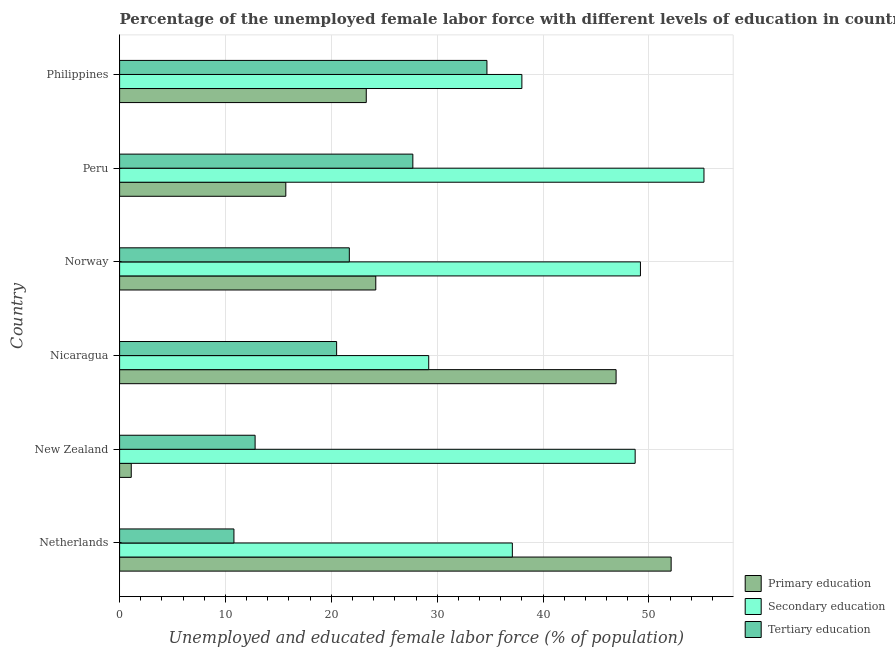How many different coloured bars are there?
Offer a very short reply. 3. How many groups of bars are there?
Your answer should be very brief. 6. How many bars are there on the 6th tick from the top?
Your answer should be compact. 3. How many bars are there on the 5th tick from the bottom?
Offer a very short reply. 3. What is the label of the 6th group of bars from the top?
Offer a terse response. Netherlands. What is the percentage of female labor force who received tertiary education in New Zealand?
Offer a terse response. 12.8. Across all countries, what is the maximum percentage of female labor force who received secondary education?
Ensure brevity in your answer.  55.2. Across all countries, what is the minimum percentage of female labor force who received primary education?
Keep it short and to the point. 1.1. In which country was the percentage of female labor force who received primary education minimum?
Ensure brevity in your answer.  New Zealand. What is the total percentage of female labor force who received tertiary education in the graph?
Your answer should be very brief. 128.2. What is the difference between the percentage of female labor force who received secondary education in Philippines and the percentage of female labor force who received primary education in Peru?
Provide a short and direct response. 22.3. What is the average percentage of female labor force who received primary education per country?
Your answer should be compact. 27.22. What is the difference between the percentage of female labor force who received secondary education and percentage of female labor force who received primary education in Netherlands?
Offer a very short reply. -15. What is the ratio of the percentage of female labor force who received secondary education in Netherlands to that in New Zealand?
Your answer should be compact. 0.76. Is the percentage of female labor force who received tertiary education in Netherlands less than that in Norway?
Provide a short and direct response. Yes. Is the difference between the percentage of female labor force who received tertiary education in New Zealand and Norway greater than the difference between the percentage of female labor force who received primary education in New Zealand and Norway?
Provide a succinct answer. Yes. What is the difference between the highest and the second highest percentage of female labor force who received secondary education?
Offer a very short reply. 6. What is the difference between the highest and the lowest percentage of female labor force who received secondary education?
Your response must be concise. 26. Is the sum of the percentage of female labor force who received tertiary education in Peru and Philippines greater than the maximum percentage of female labor force who received primary education across all countries?
Offer a terse response. Yes. What does the 1st bar from the top in Nicaragua represents?
Give a very brief answer. Tertiary education. What does the 1st bar from the bottom in Philippines represents?
Provide a short and direct response. Primary education. How many bars are there?
Your answer should be compact. 18. How many countries are there in the graph?
Give a very brief answer. 6. What is the difference between two consecutive major ticks on the X-axis?
Give a very brief answer. 10. Are the values on the major ticks of X-axis written in scientific E-notation?
Provide a short and direct response. No. Does the graph contain any zero values?
Your answer should be compact. No. Where does the legend appear in the graph?
Your response must be concise. Bottom right. How are the legend labels stacked?
Provide a succinct answer. Vertical. What is the title of the graph?
Your answer should be very brief. Percentage of the unemployed female labor force with different levels of education in countries. What is the label or title of the X-axis?
Ensure brevity in your answer.  Unemployed and educated female labor force (% of population). What is the Unemployed and educated female labor force (% of population) in Primary education in Netherlands?
Give a very brief answer. 52.1. What is the Unemployed and educated female labor force (% of population) in Secondary education in Netherlands?
Provide a succinct answer. 37.1. What is the Unemployed and educated female labor force (% of population) in Tertiary education in Netherlands?
Your response must be concise. 10.8. What is the Unemployed and educated female labor force (% of population) in Primary education in New Zealand?
Keep it short and to the point. 1.1. What is the Unemployed and educated female labor force (% of population) in Secondary education in New Zealand?
Keep it short and to the point. 48.7. What is the Unemployed and educated female labor force (% of population) of Tertiary education in New Zealand?
Keep it short and to the point. 12.8. What is the Unemployed and educated female labor force (% of population) in Primary education in Nicaragua?
Offer a terse response. 46.9. What is the Unemployed and educated female labor force (% of population) of Secondary education in Nicaragua?
Ensure brevity in your answer.  29.2. What is the Unemployed and educated female labor force (% of population) in Primary education in Norway?
Provide a succinct answer. 24.2. What is the Unemployed and educated female labor force (% of population) of Secondary education in Norway?
Your answer should be very brief. 49.2. What is the Unemployed and educated female labor force (% of population) of Tertiary education in Norway?
Make the answer very short. 21.7. What is the Unemployed and educated female labor force (% of population) of Primary education in Peru?
Provide a succinct answer. 15.7. What is the Unemployed and educated female labor force (% of population) of Secondary education in Peru?
Offer a terse response. 55.2. What is the Unemployed and educated female labor force (% of population) of Tertiary education in Peru?
Give a very brief answer. 27.7. What is the Unemployed and educated female labor force (% of population) in Primary education in Philippines?
Provide a short and direct response. 23.3. What is the Unemployed and educated female labor force (% of population) of Tertiary education in Philippines?
Give a very brief answer. 34.7. Across all countries, what is the maximum Unemployed and educated female labor force (% of population) of Primary education?
Provide a short and direct response. 52.1. Across all countries, what is the maximum Unemployed and educated female labor force (% of population) of Secondary education?
Make the answer very short. 55.2. Across all countries, what is the maximum Unemployed and educated female labor force (% of population) of Tertiary education?
Keep it short and to the point. 34.7. Across all countries, what is the minimum Unemployed and educated female labor force (% of population) of Primary education?
Your answer should be compact. 1.1. Across all countries, what is the minimum Unemployed and educated female labor force (% of population) in Secondary education?
Ensure brevity in your answer.  29.2. Across all countries, what is the minimum Unemployed and educated female labor force (% of population) of Tertiary education?
Offer a terse response. 10.8. What is the total Unemployed and educated female labor force (% of population) in Primary education in the graph?
Your response must be concise. 163.3. What is the total Unemployed and educated female labor force (% of population) of Secondary education in the graph?
Provide a succinct answer. 257.4. What is the total Unemployed and educated female labor force (% of population) in Tertiary education in the graph?
Provide a succinct answer. 128.2. What is the difference between the Unemployed and educated female labor force (% of population) in Primary education in Netherlands and that in Nicaragua?
Your response must be concise. 5.2. What is the difference between the Unemployed and educated female labor force (% of population) of Primary education in Netherlands and that in Norway?
Give a very brief answer. 27.9. What is the difference between the Unemployed and educated female labor force (% of population) of Primary education in Netherlands and that in Peru?
Provide a succinct answer. 36.4. What is the difference between the Unemployed and educated female labor force (% of population) in Secondary education in Netherlands and that in Peru?
Provide a short and direct response. -18.1. What is the difference between the Unemployed and educated female labor force (% of population) in Tertiary education in Netherlands and that in Peru?
Give a very brief answer. -16.9. What is the difference between the Unemployed and educated female labor force (% of population) in Primary education in Netherlands and that in Philippines?
Offer a very short reply. 28.8. What is the difference between the Unemployed and educated female labor force (% of population) of Tertiary education in Netherlands and that in Philippines?
Give a very brief answer. -23.9. What is the difference between the Unemployed and educated female labor force (% of population) in Primary education in New Zealand and that in Nicaragua?
Give a very brief answer. -45.8. What is the difference between the Unemployed and educated female labor force (% of population) in Primary education in New Zealand and that in Norway?
Keep it short and to the point. -23.1. What is the difference between the Unemployed and educated female labor force (% of population) of Primary education in New Zealand and that in Peru?
Your answer should be compact. -14.6. What is the difference between the Unemployed and educated female labor force (% of population) of Tertiary education in New Zealand and that in Peru?
Your answer should be very brief. -14.9. What is the difference between the Unemployed and educated female labor force (% of population) in Primary education in New Zealand and that in Philippines?
Provide a short and direct response. -22.2. What is the difference between the Unemployed and educated female labor force (% of population) in Tertiary education in New Zealand and that in Philippines?
Your answer should be very brief. -21.9. What is the difference between the Unemployed and educated female labor force (% of population) of Primary education in Nicaragua and that in Norway?
Provide a short and direct response. 22.7. What is the difference between the Unemployed and educated female labor force (% of population) of Secondary education in Nicaragua and that in Norway?
Ensure brevity in your answer.  -20. What is the difference between the Unemployed and educated female labor force (% of population) in Tertiary education in Nicaragua and that in Norway?
Make the answer very short. -1.2. What is the difference between the Unemployed and educated female labor force (% of population) of Primary education in Nicaragua and that in Peru?
Offer a very short reply. 31.2. What is the difference between the Unemployed and educated female labor force (% of population) in Secondary education in Nicaragua and that in Peru?
Offer a terse response. -26. What is the difference between the Unemployed and educated female labor force (% of population) of Primary education in Nicaragua and that in Philippines?
Provide a succinct answer. 23.6. What is the difference between the Unemployed and educated female labor force (% of population) of Secondary education in Norway and that in Philippines?
Your answer should be compact. 11.2. What is the difference between the Unemployed and educated female labor force (% of population) in Tertiary education in Norway and that in Philippines?
Offer a terse response. -13. What is the difference between the Unemployed and educated female labor force (% of population) in Primary education in Peru and that in Philippines?
Ensure brevity in your answer.  -7.6. What is the difference between the Unemployed and educated female labor force (% of population) of Secondary education in Peru and that in Philippines?
Give a very brief answer. 17.2. What is the difference between the Unemployed and educated female labor force (% of population) in Primary education in Netherlands and the Unemployed and educated female labor force (% of population) in Tertiary education in New Zealand?
Ensure brevity in your answer.  39.3. What is the difference between the Unemployed and educated female labor force (% of population) in Secondary education in Netherlands and the Unemployed and educated female labor force (% of population) in Tertiary education in New Zealand?
Offer a very short reply. 24.3. What is the difference between the Unemployed and educated female labor force (% of population) in Primary education in Netherlands and the Unemployed and educated female labor force (% of population) in Secondary education in Nicaragua?
Your answer should be very brief. 22.9. What is the difference between the Unemployed and educated female labor force (% of population) in Primary education in Netherlands and the Unemployed and educated female labor force (% of population) in Tertiary education in Nicaragua?
Offer a very short reply. 31.6. What is the difference between the Unemployed and educated female labor force (% of population) in Primary education in Netherlands and the Unemployed and educated female labor force (% of population) in Secondary education in Norway?
Keep it short and to the point. 2.9. What is the difference between the Unemployed and educated female labor force (% of population) in Primary education in Netherlands and the Unemployed and educated female labor force (% of population) in Tertiary education in Norway?
Provide a succinct answer. 30.4. What is the difference between the Unemployed and educated female labor force (% of population) in Primary education in Netherlands and the Unemployed and educated female labor force (% of population) in Tertiary education in Peru?
Your answer should be very brief. 24.4. What is the difference between the Unemployed and educated female labor force (% of population) in Secondary education in Netherlands and the Unemployed and educated female labor force (% of population) in Tertiary education in Peru?
Make the answer very short. 9.4. What is the difference between the Unemployed and educated female labor force (% of population) of Primary education in Netherlands and the Unemployed and educated female labor force (% of population) of Tertiary education in Philippines?
Keep it short and to the point. 17.4. What is the difference between the Unemployed and educated female labor force (% of population) in Secondary education in Netherlands and the Unemployed and educated female labor force (% of population) in Tertiary education in Philippines?
Your answer should be very brief. 2.4. What is the difference between the Unemployed and educated female labor force (% of population) of Primary education in New Zealand and the Unemployed and educated female labor force (% of population) of Secondary education in Nicaragua?
Give a very brief answer. -28.1. What is the difference between the Unemployed and educated female labor force (% of population) in Primary education in New Zealand and the Unemployed and educated female labor force (% of population) in Tertiary education in Nicaragua?
Give a very brief answer. -19.4. What is the difference between the Unemployed and educated female labor force (% of population) of Secondary education in New Zealand and the Unemployed and educated female labor force (% of population) of Tertiary education in Nicaragua?
Your answer should be very brief. 28.2. What is the difference between the Unemployed and educated female labor force (% of population) of Primary education in New Zealand and the Unemployed and educated female labor force (% of population) of Secondary education in Norway?
Provide a succinct answer. -48.1. What is the difference between the Unemployed and educated female labor force (% of population) of Primary education in New Zealand and the Unemployed and educated female labor force (% of population) of Tertiary education in Norway?
Ensure brevity in your answer.  -20.6. What is the difference between the Unemployed and educated female labor force (% of population) in Primary education in New Zealand and the Unemployed and educated female labor force (% of population) in Secondary education in Peru?
Offer a terse response. -54.1. What is the difference between the Unemployed and educated female labor force (% of population) of Primary education in New Zealand and the Unemployed and educated female labor force (% of population) of Tertiary education in Peru?
Provide a short and direct response. -26.6. What is the difference between the Unemployed and educated female labor force (% of population) in Primary education in New Zealand and the Unemployed and educated female labor force (% of population) in Secondary education in Philippines?
Keep it short and to the point. -36.9. What is the difference between the Unemployed and educated female labor force (% of population) in Primary education in New Zealand and the Unemployed and educated female labor force (% of population) in Tertiary education in Philippines?
Offer a very short reply. -33.6. What is the difference between the Unemployed and educated female labor force (% of population) in Primary education in Nicaragua and the Unemployed and educated female labor force (% of population) in Tertiary education in Norway?
Your answer should be compact. 25.2. What is the difference between the Unemployed and educated female labor force (% of population) of Primary education in Nicaragua and the Unemployed and educated female labor force (% of population) of Secondary education in Peru?
Ensure brevity in your answer.  -8.3. What is the difference between the Unemployed and educated female labor force (% of population) in Primary education in Nicaragua and the Unemployed and educated female labor force (% of population) in Tertiary education in Peru?
Your response must be concise. 19.2. What is the difference between the Unemployed and educated female labor force (% of population) in Primary education in Nicaragua and the Unemployed and educated female labor force (% of population) in Tertiary education in Philippines?
Make the answer very short. 12.2. What is the difference between the Unemployed and educated female labor force (% of population) in Secondary education in Nicaragua and the Unemployed and educated female labor force (% of population) in Tertiary education in Philippines?
Your answer should be very brief. -5.5. What is the difference between the Unemployed and educated female labor force (% of population) in Primary education in Norway and the Unemployed and educated female labor force (% of population) in Secondary education in Peru?
Give a very brief answer. -31. What is the difference between the Unemployed and educated female labor force (% of population) in Primary education in Norway and the Unemployed and educated female labor force (% of population) in Tertiary education in Peru?
Ensure brevity in your answer.  -3.5. What is the difference between the Unemployed and educated female labor force (% of population) of Primary education in Norway and the Unemployed and educated female labor force (% of population) of Secondary education in Philippines?
Offer a very short reply. -13.8. What is the difference between the Unemployed and educated female labor force (% of population) of Primary education in Norway and the Unemployed and educated female labor force (% of population) of Tertiary education in Philippines?
Your answer should be very brief. -10.5. What is the difference between the Unemployed and educated female labor force (% of population) in Primary education in Peru and the Unemployed and educated female labor force (% of population) in Secondary education in Philippines?
Offer a terse response. -22.3. What is the difference between the Unemployed and educated female labor force (% of population) in Primary education in Peru and the Unemployed and educated female labor force (% of population) in Tertiary education in Philippines?
Provide a short and direct response. -19. What is the average Unemployed and educated female labor force (% of population) of Primary education per country?
Provide a short and direct response. 27.22. What is the average Unemployed and educated female labor force (% of population) in Secondary education per country?
Your answer should be very brief. 42.9. What is the average Unemployed and educated female labor force (% of population) in Tertiary education per country?
Your answer should be compact. 21.37. What is the difference between the Unemployed and educated female labor force (% of population) of Primary education and Unemployed and educated female labor force (% of population) of Secondary education in Netherlands?
Ensure brevity in your answer.  15. What is the difference between the Unemployed and educated female labor force (% of population) in Primary education and Unemployed and educated female labor force (% of population) in Tertiary education in Netherlands?
Offer a terse response. 41.3. What is the difference between the Unemployed and educated female labor force (% of population) of Secondary education and Unemployed and educated female labor force (% of population) of Tertiary education in Netherlands?
Give a very brief answer. 26.3. What is the difference between the Unemployed and educated female labor force (% of population) of Primary education and Unemployed and educated female labor force (% of population) of Secondary education in New Zealand?
Offer a very short reply. -47.6. What is the difference between the Unemployed and educated female labor force (% of population) in Secondary education and Unemployed and educated female labor force (% of population) in Tertiary education in New Zealand?
Your response must be concise. 35.9. What is the difference between the Unemployed and educated female labor force (% of population) in Primary education and Unemployed and educated female labor force (% of population) in Tertiary education in Nicaragua?
Ensure brevity in your answer.  26.4. What is the difference between the Unemployed and educated female labor force (% of population) in Primary education and Unemployed and educated female labor force (% of population) in Secondary education in Norway?
Offer a terse response. -25. What is the difference between the Unemployed and educated female labor force (% of population) of Secondary education and Unemployed and educated female labor force (% of population) of Tertiary education in Norway?
Offer a terse response. 27.5. What is the difference between the Unemployed and educated female labor force (% of population) of Primary education and Unemployed and educated female labor force (% of population) of Secondary education in Peru?
Provide a short and direct response. -39.5. What is the difference between the Unemployed and educated female labor force (% of population) of Primary education and Unemployed and educated female labor force (% of population) of Tertiary education in Peru?
Ensure brevity in your answer.  -12. What is the difference between the Unemployed and educated female labor force (% of population) of Secondary education and Unemployed and educated female labor force (% of population) of Tertiary education in Peru?
Ensure brevity in your answer.  27.5. What is the difference between the Unemployed and educated female labor force (% of population) in Primary education and Unemployed and educated female labor force (% of population) in Secondary education in Philippines?
Make the answer very short. -14.7. What is the difference between the Unemployed and educated female labor force (% of population) of Primary education and Unemployed and educated female labor force (% of population) of Tertiary education in Philippines?
Keep it short and to the point. -11.4. What is the ratio of the Unemployed and educated female labor force (% of population) of Primary education in Netherlands to that in New Zealand?
Offer a terse response. 47.36. What is the ratio of the Unemployed and educated female labor force (% of population) in Secondary education in Netherlands to that in New Zealand?
Your answer should be compact. 0.76. What is the ratio of the Unemployed and educated female labor force (% of population) of Tertiary education in Netherlands to that in New Zealand?
Your answer should be very brief. 0.84. What is the ratio of the Unemployed and educated female labor force (% of population) of Primary education in Netherlands to that in Nicaragua?
Provide a short and direct response. 1.11. What is the ratio of the Unemployed and educated female labor force (% of population) in Secondary education in Netherlands to that in Nicaragua?
Provide a succinct answer. 1.27. What is the ratio of the Unemployed and educated female labor force (% of population) of Tertiary education in Netherlands to that in Nicaragua?
Offer a very short reply. 0.53. What is the ratio of the Unemployed and educated female labor force (% of population) in Primary education in Netherlands to that in Norway?
Provide a succinct answer. 2.15. What is the ratio of the Unemployed and educated female labor force (% of population) in Secondary education in Netherlands to that in Norway?
Offer a terse response. 0.75. What is the ratio of the Unemployed and educated female labor force (% of population) of Tertiary education in Netherlands to that in Norway?
Give a very brief answer. 0.5. What is the ratio of the Unemployed and educated female labor force (% of population) in Primary education in Netherlands to that in Peru?
Your answer should be very brief. 3.32. What is the ratio of the Unemployed and educated female labor force (% of population) of Secondary education in Netherlands to that in Peru?
Provide a succinct answer. 0.67. What is the ratio of the Unemployed and educated female labor force (% of population) in Tertiary education in Netherlands to that in Peru?
Your answer should be compact. 0.39. What is the ratio of the Unemployed and educated female labor force (% of population) of Primary education in Netherlands to that in Philippines?
Provide a short and direct response. 2.24. What is the ratio of the Unemployed and educated female labor force (% of population) of Secondary education in Netherlands to that in Philippines?
Provide a succinct answer. 0.98. What is the ratio of the Unemployed and educated female labor force (% of population) of Tertiary education in Netherlands to that in Philippines?
Your answer should be very brief. 0.31. What is the ratio of the Unemployed and educated female labor force (% of population) in Primary education in New Zealand to that in Nicaragua?
Provide a succinct answer. 0.02. What is the ratio of the Unemployed and educated female labor force (% of population) in Secondary education in New Zealand to that in Nicaragua?
Provide a short and direct response. 1.67. What is the ratio of the Unemployed and educated female labor force (% of population) in Tertiary education in New Zealand to that in Nicaragua?
Keep it short and to the point. 0.62. What is the ratio of the Unemployed and educated female labor force (% of population) of Primary education in New Zealand to that in Norway?
Offer a terse response. 0.05. What is the ratio of the Unemployed and educated female labor force (% of population) of Secondary education in New Zealand to that in Norway?
Offer a terse response. 0.99. What is the ratio of the Unemployed and educated female labor force (% of population) in Tertiary education in New Zealand to that in Norway?
Your response must be concise. 0.59. What is the ratio of the Unemployed and educated female labor force (% of population) of Primary education in New Zealand to that in Peru?
Ensure brevity in your answer.  0.07. What is the ratio of the Unemployed and educated female labor force (% of population) in Secondary education in New Zealand to that in Peru?
Your response must be concise. 0.88. What is the ratio of the Unemployed and educated female labor force (% of population) in Tertiary education in New Zealand to that in Peru?
Ensure brevity in your answer.  0.46. What is the ratio of the Unemployed and educated female labor force (% of population) in Primary education in New Zealand to that in Philippines?
Your response must be concise. 0.05. What is the ratio of the Unemployed and educated female labor force (% of population) of Secondary education in New Zealand to that in Philippines?
Give a very brief answer. 1.28. What is the ratio of the Unemployed and educated female labor force (% of population) of Tertiary education in New Zealand to that in Philippines?
Your answer should be very brief. 0.37. What is the ratio of the Unemployed and educated female labor force (% of population) in Primary education in Nicaragua to that in Norway?
Ensure brevity in your answer.  1.94. What is the ratio of the Unemployed and educated female labor force (% of population) of Secondary education in Nicaragua to that in Norway?
Give a very brief answer. 0.59. What is the ratio of the Unemployed and educated female labor force (% of population) in Tertiary education in Nicaragua to that in Norway?
Make the answer very short. 0.94. What is the ratio of the Unemployed and educated female labor force (% of population) in Primary education in Nicaragua to that in Peru?
Offer a very short reply. 2.99. What is the ratio of the Unemployed and educated female labor force (% of population) of Secondary education in Nicaragua to that in Peru?
Your answer should be compact. 0.53. What is the ratio of the Unemployed and educated female labor force (% of population) in Tertiary education in Nicaragua to that in Peru?
Provide a succinct answer. 0.74. What is the ratio of the Unemployed and educated female labor force (% of population) in Primary education in Nicaragua to that in Philippines?
Give a very brief answer. 2.01. What is the ratio of the Unemployed and educated female labor force (% of population) of Secondary education in Nicaragua to that in Philippines?
Ensure brevity in your answer.  0.77. What is the ratio of the Unemployed and educated female labor force (% of population) of Tertiary education in Nicaragua to that in Philippines?
Your response must be concise. 0.59. What is the ratio of the Unemployed and educated female labor force (% of population) of Primary education in Norway to that in Peru?
Keep it short and to the point. 1.54. What is the ratio of the Unemployed and educated female labor force (% of population) in Secondary education in Norway to that in Peru?
Give a very brief answer. 0.89. What is the ratio of the Unemployed and educated female labor force (% of population) of Tertiary education in Norway to that in Peru?
Provide a short and direct response. 0.78. What is the ratio of the Unemployed and educated female labor force (% of population) in Primary education in Norway to that in Philippines?
Offer a very short reply. 1.04. What is the ratio of the Unemployed and educated female labor force (% of population) in Secondary education in Norway to that in Philippines?
Offer a very short reply. 1.29. What is the ratio of the Unemployed and educated female labor force (% of population) of Tertiary education in Norway to that in Philippines?
Give a very brief answer. 0.63. What is the ratio of the Unemployed and educated female labor force (% of population) of Primary education in Peru to that in Philippines?
Ensure brevity in your answer.  0.67. What is the ratio of the Unemployed and educated female labor force (% of population) of Secondary education in Peru to that in Philippines?
Your response must be concise. 1.45. What is the ratio of the Unemployed and educated female labor force (% of population) in Tertiary education in Peru to that in Philippines?
Offer a very short reply. 0.8. What is the difference between the highest and the second highest Unemployed and educated female labor force (% of population) of Secondary education?
Your answer should be compact. 6. What is the difference between the highest and the lowest Unemployed and educated female labor force (% of population) of Primary education?
Provide a succinct answer. 51. What is the difference between the highest and the lowest Unemployed and educated female labor force (% of population) in Secondary education?
Provide a succinct answer. 26. What is the difference between the highest and the lowest Unemployed and educated female labor force (% of population) of Tertiary education?
Your response must be concise. 23.9. 